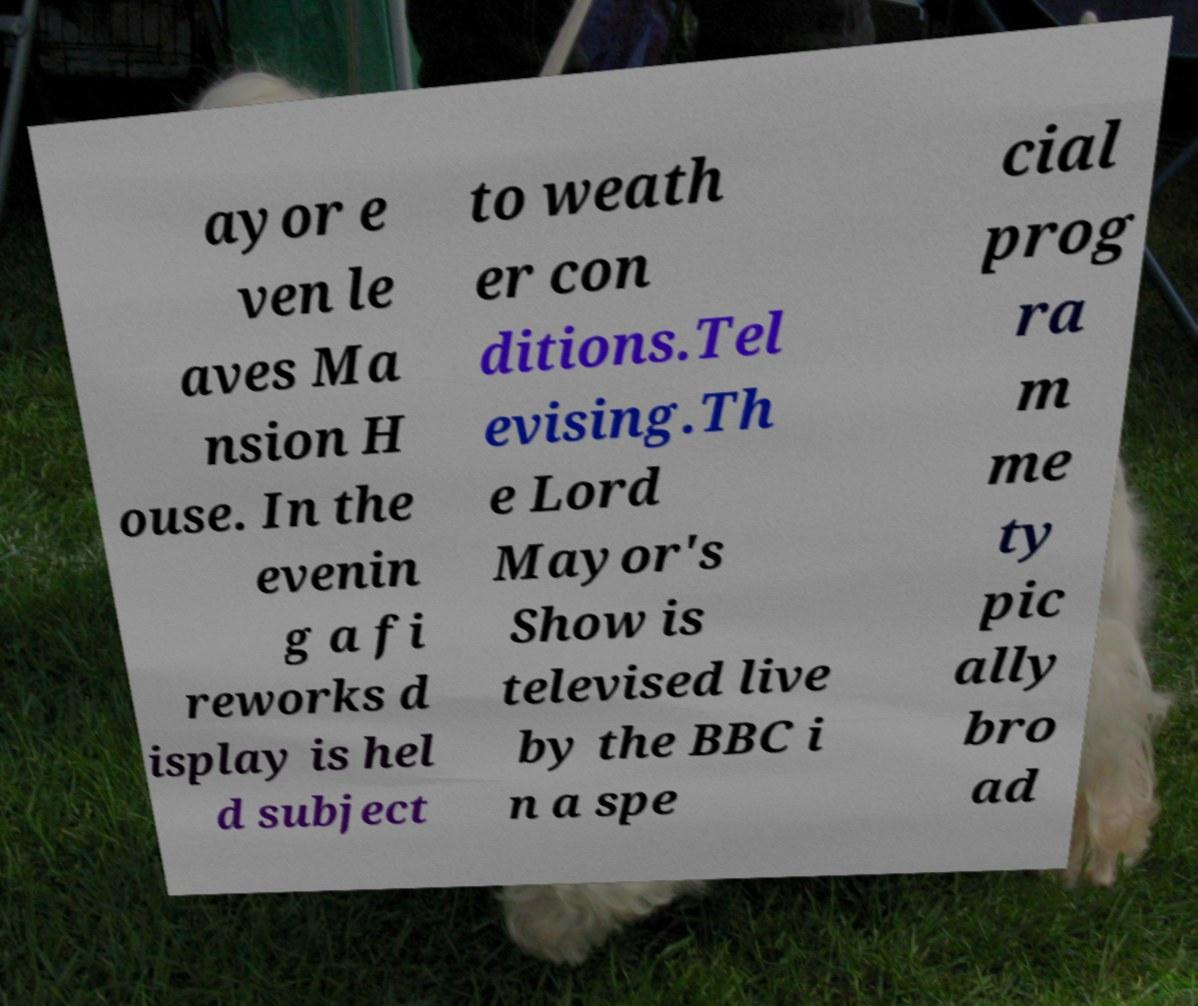What messages or text are displayed in this image? I need them in a readable, typed format. ayor e ven le aves Ma nsion H ouse. In the evenin g a fi reworks d isplay is hel d subject to weath er con ditions.Tel evising.Th e Lord Mayor's Show is televised live by the BBC i n a spe cial prog ra m me ty pic ally bro ad 